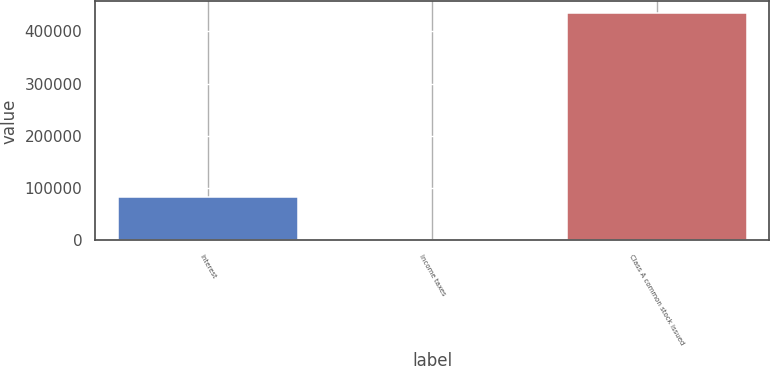Convert chart. <chart><loc_0><loc_0><loc_500><loc_500><bar_chart><fcel>Interest<fcel>Income taxes<fcel>Class A common stock issued<nl><fcel>82215<fcel>1158<fcel>435857<nl></chart> 